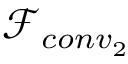<formula> <loc_0><loc_0><loc_500><loc_500>\ m a t h s c r { F } _ { c o n v _ { 2 } }</formula> 